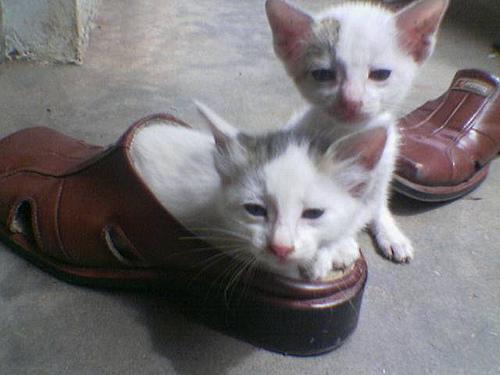How many kittens are there?
Short answer required. 2. What color are the kittens?
Short answer required. White. Is the kitten in a shoe?
Concise answer only. Yes. Can the cat get from the floor to the counter without assistance?
Quick response, please. No. 